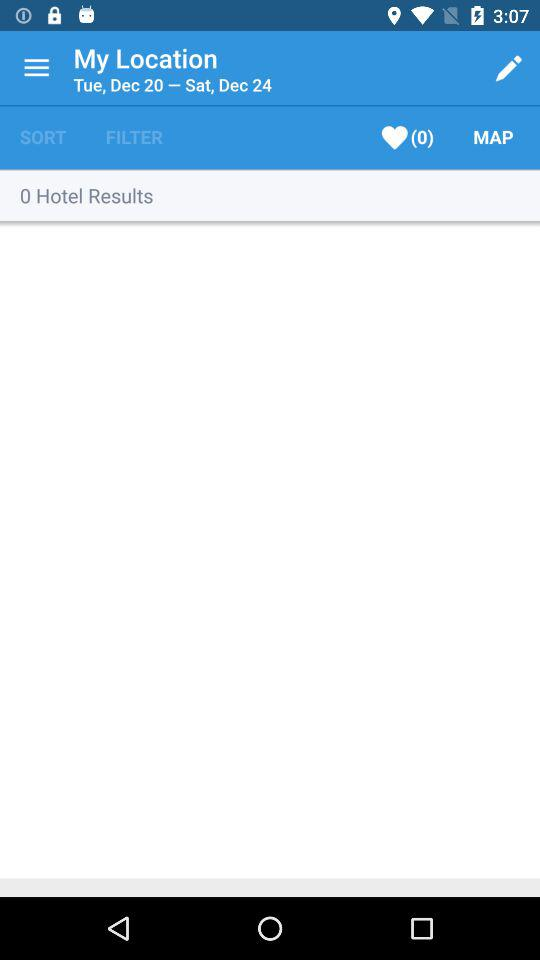How many days are in the search range?
Answer the question using a single word or phrase. 5 